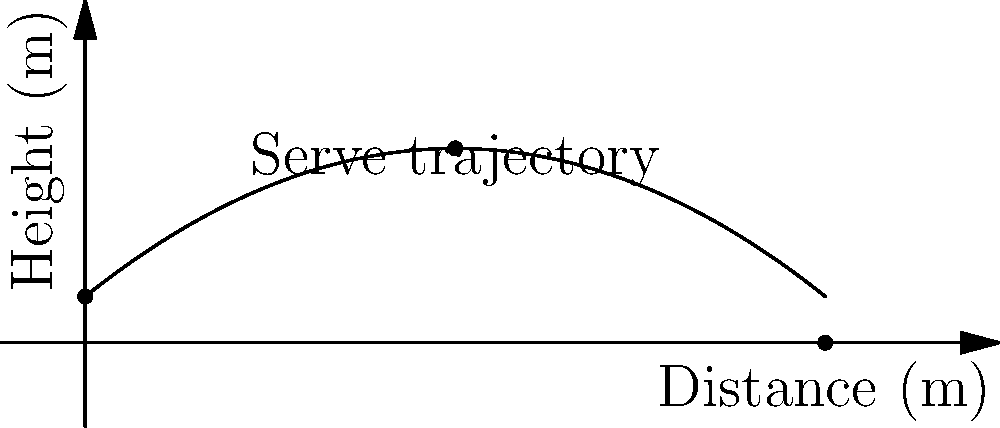As a tennis enthusiast and Novak Djokovic fan, you're analyzing his powerful serve. The trajectory of Djokovic's serve can be modeled by the function $h(x) = -0.05x^2 + 0.8x + 1$, where $h$ is the height of the ball in meters and $x$ is the horizontal distance from the server in meters. At what horizontal distance from Djokovic does the ball reach its maximum height? To find the maximum height of the serve, we need to follow these steps:

1) The function given is a quadratic function in the form $f(x) = ax^2 + bx + c$, where:
   $a = -0.05$
   $b = 0.8$
   $c = 1$

2) For a quadratic function, the x-coordinate of the vertex represents the point where the function reaches its maximum (if $a < 0$) or minimum (if $a > 0$).

3) The formula for the x-coordinate of the vertex is: $x = -\frac{b}{2a}$

4) Substituting our values:
   $x = -\frac{0.8}{2(-0.05)} = \frac{0.8}{0.1} = 8$

5) Therefore, the ball reaches its maximum height when $x = 8$ meters.

This means that Djokovic's serve reaches its peak 8 meters away from where he's serving, showcasing the power and precision of his serve technique.
Answer: 8 meters 